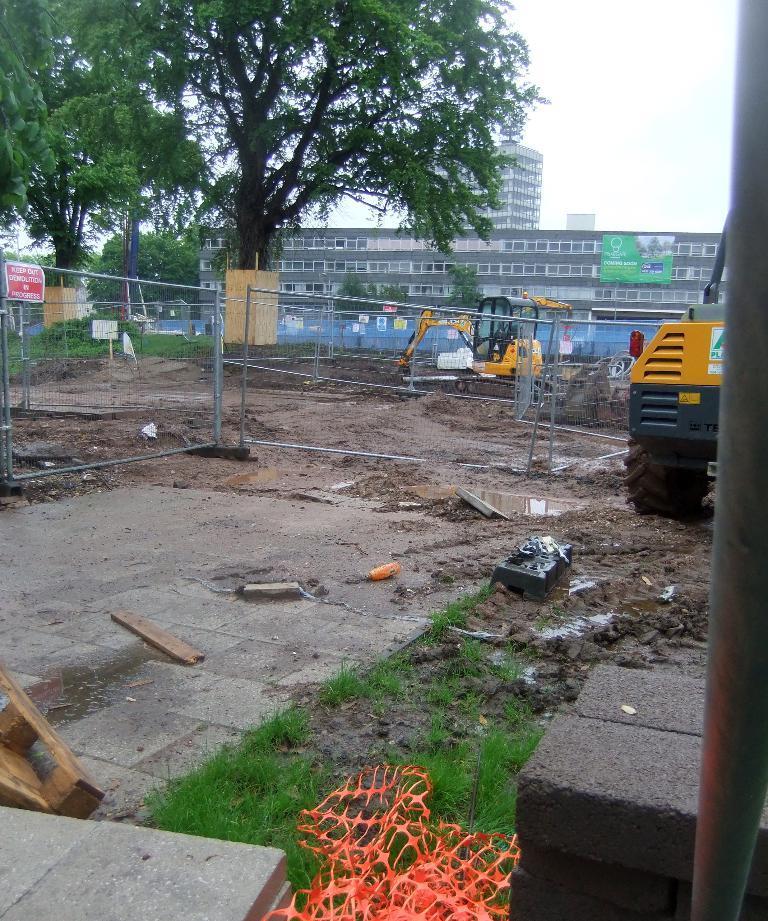How would you summarize this image in a sentence or two? In this picture there are buildings and there are trees. In the foreground there are vehicles and there is a fence and there is a board on the fence and there is text on the board and there are wooden objects and there are bricks. On the left side of the image there is a pole. At the back there is a board on the building. At the top there is sky. At the bottom there is ground and there is grass and there is a floor. 